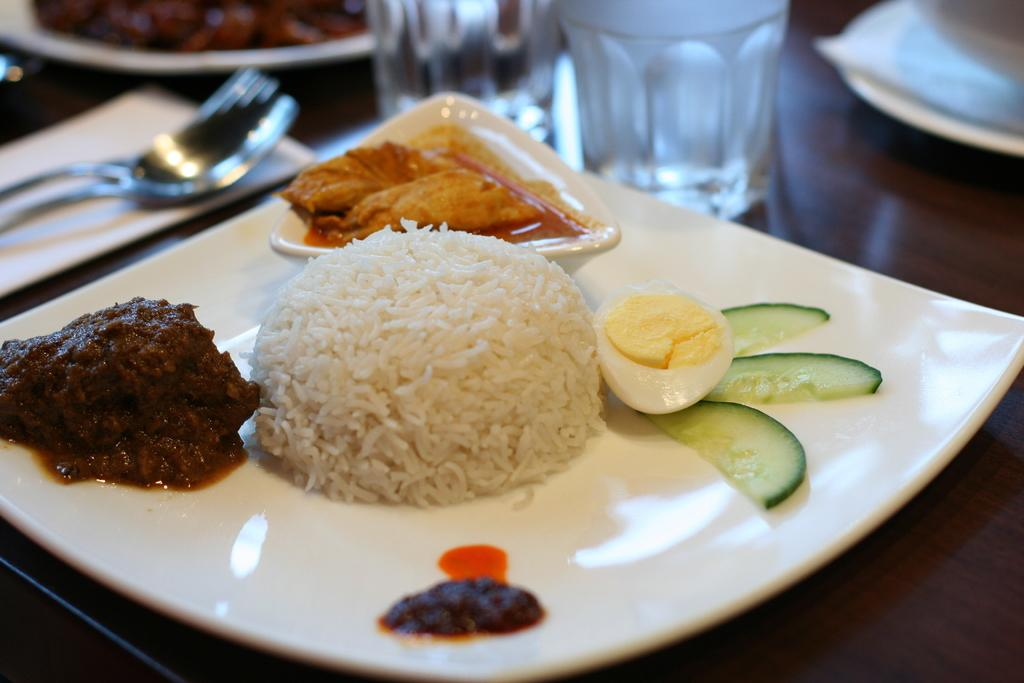What is located in the foreground of the image? There is a plate in the foreground of the image. What is on the plate? The plate contains food items. What type of items can be seen on the table? There are glass items, plates, spoons, and tissue items on the table. What type of structure can be seen providing shade for the table in the image? There is no structure providing shade for the table in the image. How many legs can be seen supporting the table in the image? The image does not show the legs of the table, so it cannot be determined from the image. 